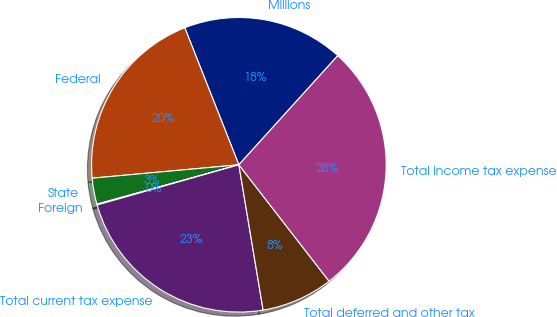Convert chart. <chart><loc_0><loc_0><loc_500><loc_500><pie_chart><fcel>Millions<fcel>Federal<fcel>State<fcel>Foreign<fcel>Total current tax expense<fcel>Total deferred and other tax<fcel>Total income tax expense<nl><fcel>17.7%<fcel>20.47%<fcel>2.86%<fcel>0.09%<fcel>23.24%<fcel>7.86%<fcel>27.79%<nl></chart> 